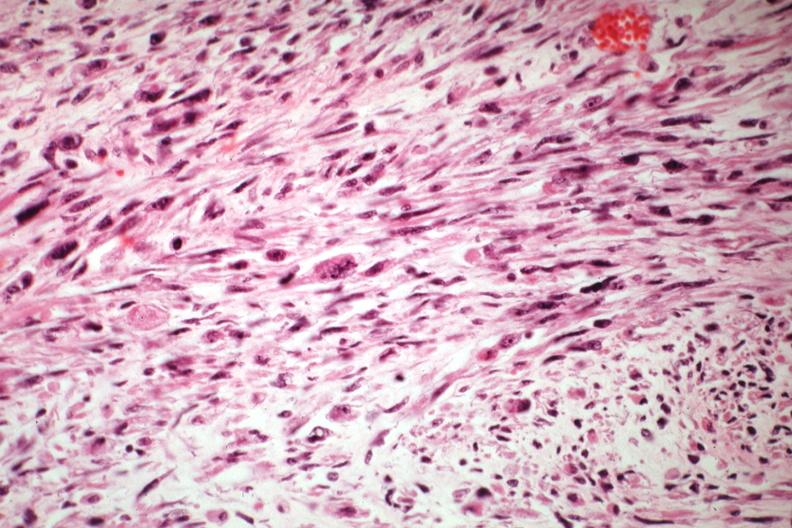s female reproductive present?
Answer the question using a single word or phrase. Yes 